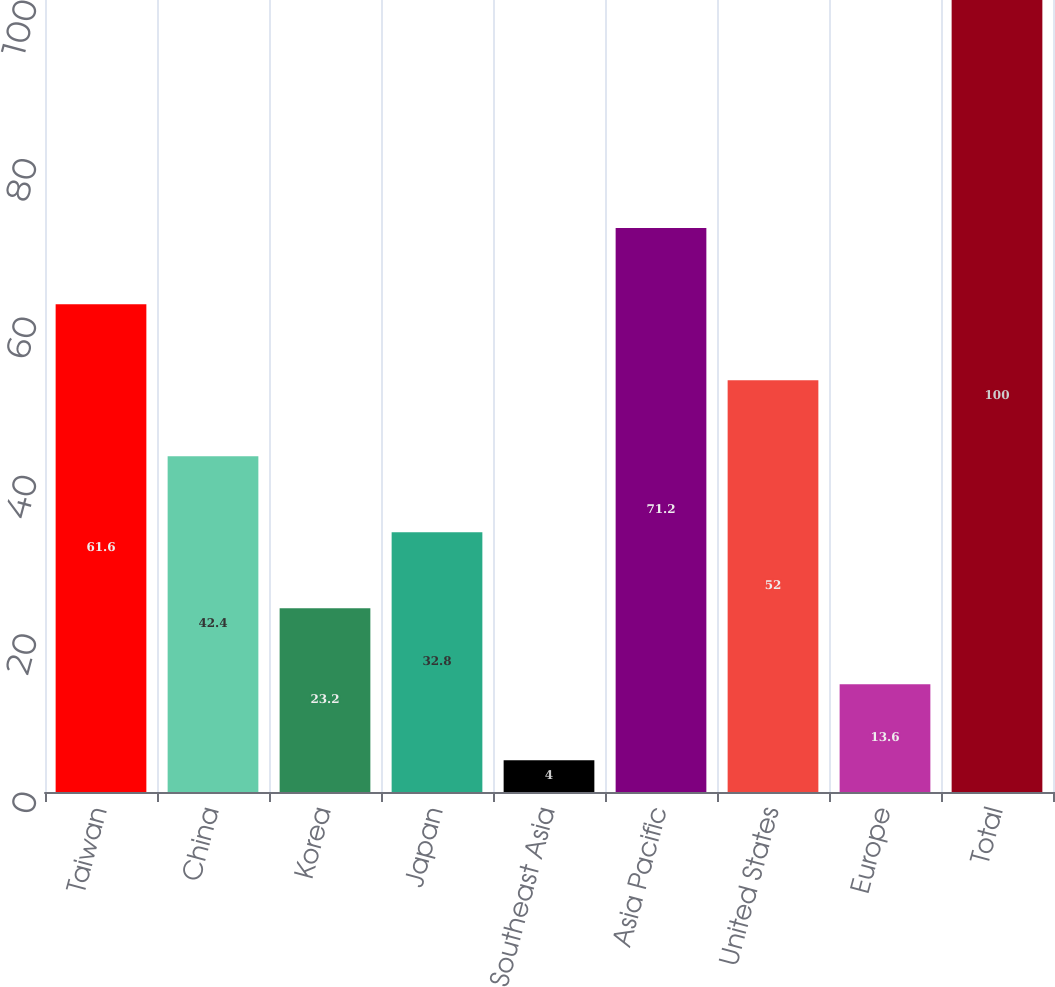<chart> <loc_0><loc_0><loc_500><loc_500><bar_chart><fcel>Taiwan<fcel>China<fcel>Korea<fcel>Japan<fcel>Southeast Asia<fcel>Asia Pacific<fcel>United States<fcel>Europe<fcel>Total<nl><fcel>61.6<fcel>42.4<fcel>23.2<fcel>32.8<fcel>4<fcel>71.2<fcel>52<fcel>13.6<fcel>100<nl></chart> 